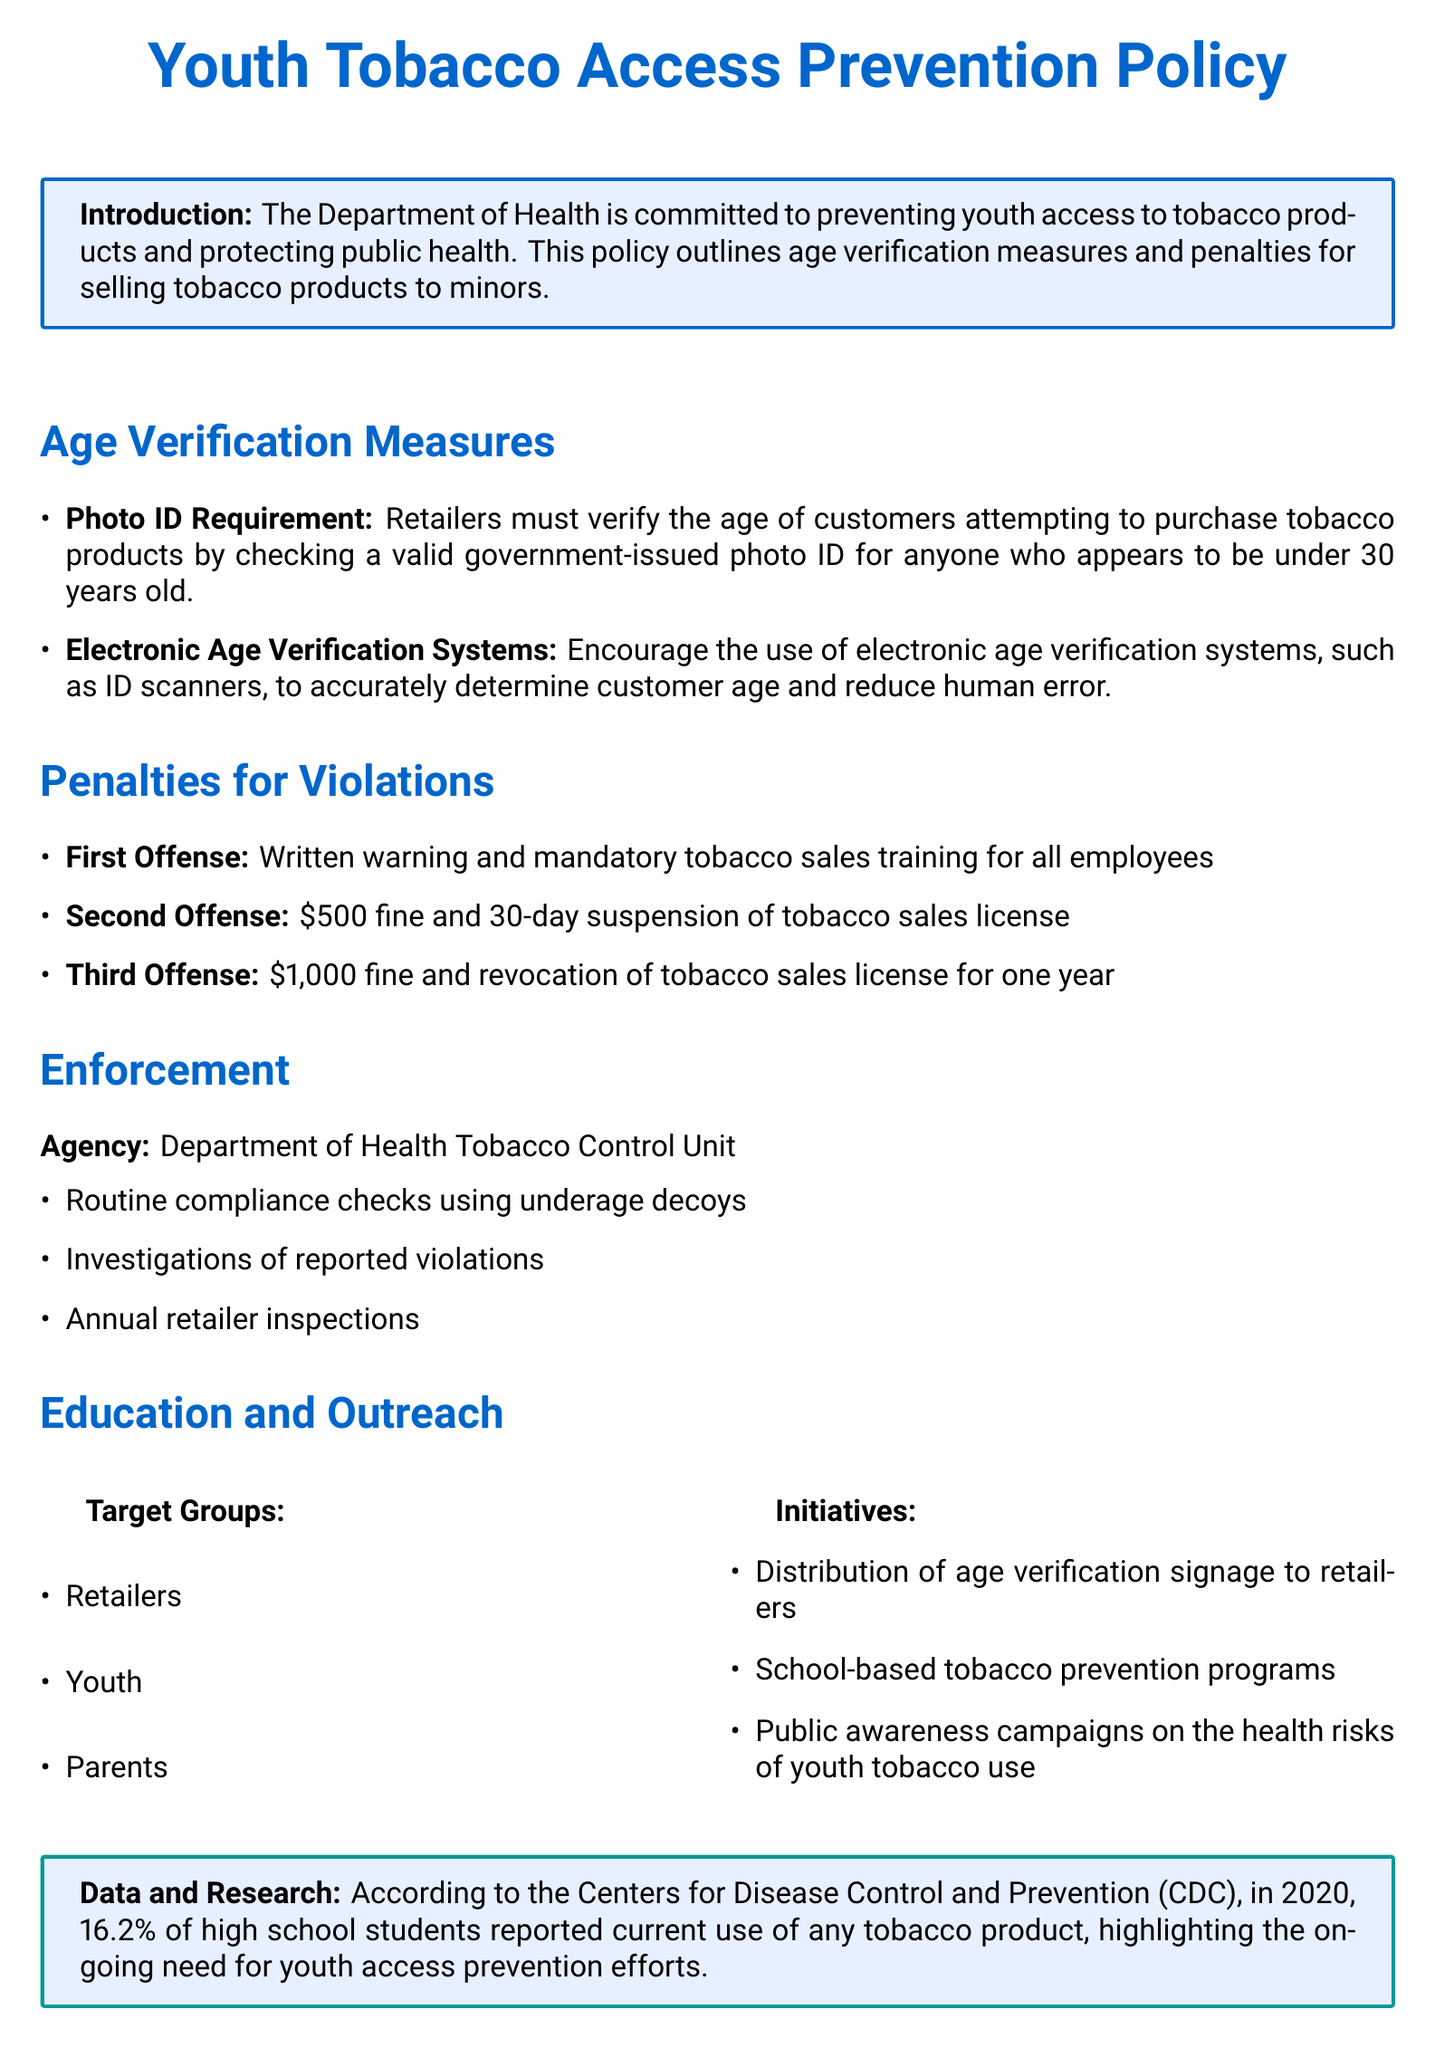What is the primary objective of the Youth Tobacco Access Prevention Policy? The primary objective outlined in the introduction is to prevent youth access to tobacco products and protect public health.
Answer: Prevent youth access to tobacco products What age must customers be to be exempt from requiring a photo ID? According to the age verification measures, retailers must verify age for customers who appear to be under 30 years old.
Answer: Under 30 years old What is the fine for a second offense of selling tobacco to minors? The penalty listed for a second offense is mentioned in the penalties section.
Answer: $500 What is the agency responsible for enforcement of this policy? The enforcement section specifies that the responsible agency is the Department of Health Tobacco Control Unit.
Answer: Department of Health Tobacco Control Unit Which initiative is aimed at educating retailers about tobacco sales? The education and outreach section mentions the distribution of age verification signage to retailers as an initiative.
Answer: Age verification signage What consequence comes after a third offense? The penalties section states that after a third offense, the consequence is revocation of the tobacco sales license for one year.
Answer: Revocation of tobacco sales license for one year What percentage of high school students reported tobacco use in 2020? The data and research section cites the percentage of high school students who reported current tobacco use according to the CDC.
Answer: 16.2% Which groups are targeted for education initiatives? The education and outreach section identifies specific target groups for initiatives, stating they include retailers, youth, and parents.
Answer: Retailers, youth, parents What type of checks does the enforcement agency use? The enforcement measures discuss routine compliance checks using specific methods to ensure adherence to the policy.
Answer: Underage decoys 